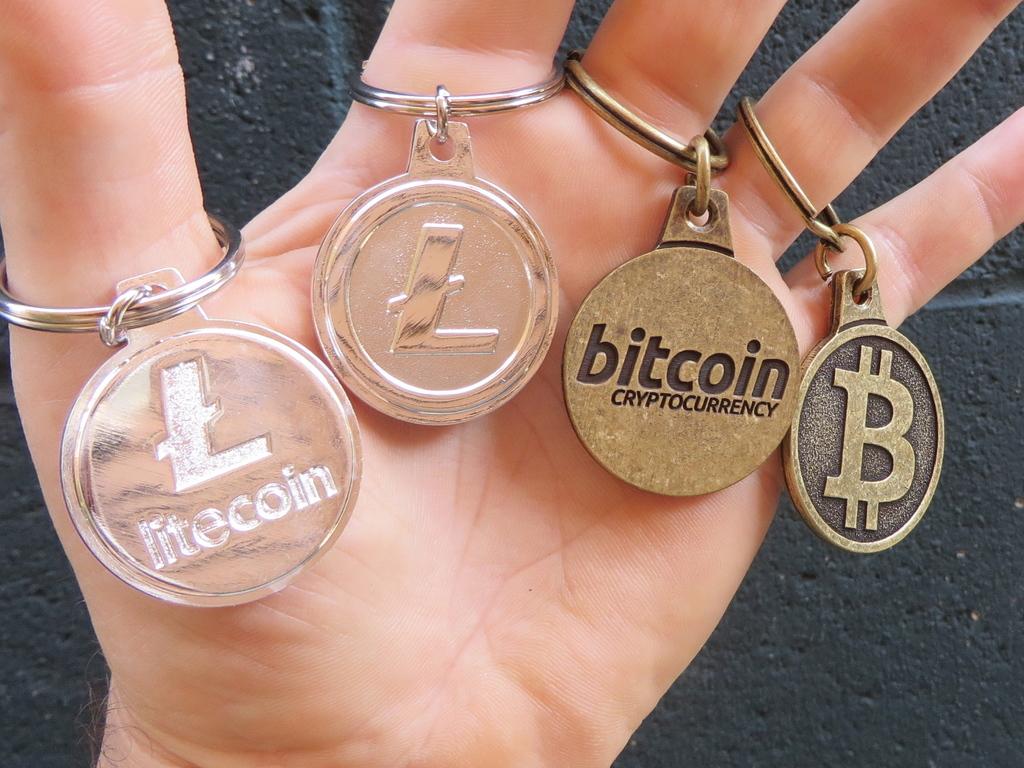Which letter is on the medallion on the pinkie finger?
Provide a succinct answer. B. 